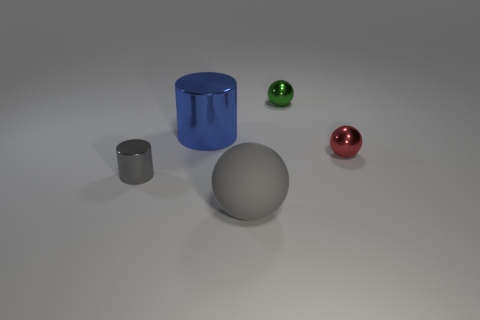Are there any other things that are the same material as the large sphere?
Ensure brevity in your answer.  No. What size is the other metallic thing that is the same shape as the red object?
Ensure brevity in your answer.  Small. Do the rubber ball and the small metallic cylinder have the same color?
Ensure brevity in your answer.  Yes. There is a gray thing right of the small object to the left of the big gray sphere; what number of gray balls are in front of it?
Provide a short and direct response. 0. Is the number of large blue metal cylinders greater than the number of tiny green cylinders?
Your answer should be very brief. Yes. How many blue things are there?
Make the answer very short. 1. There is a gray thing to the left of the large thing that is in front of the small shiny thing on the left side of the gray rubber thing; what shape is it?
Offer a terse response. Cylinder. Is the number of tiny metallic spheres that are behind the tiny green ball less than the number of gray matte spheres on the left side of the small red metal thing?
Your answer should be very brief. Yes. Do the tiny metal thing that is on the right side of the small green thing and the thing that is behind the big blue shiny cylinder have the same shape?
Make the answer very short. Yes. There is a tiny shiny object that is behind the cylinder that is behind the tiny gray metallic thing; what is its shape?
Offer a very short reply. Sphere. 